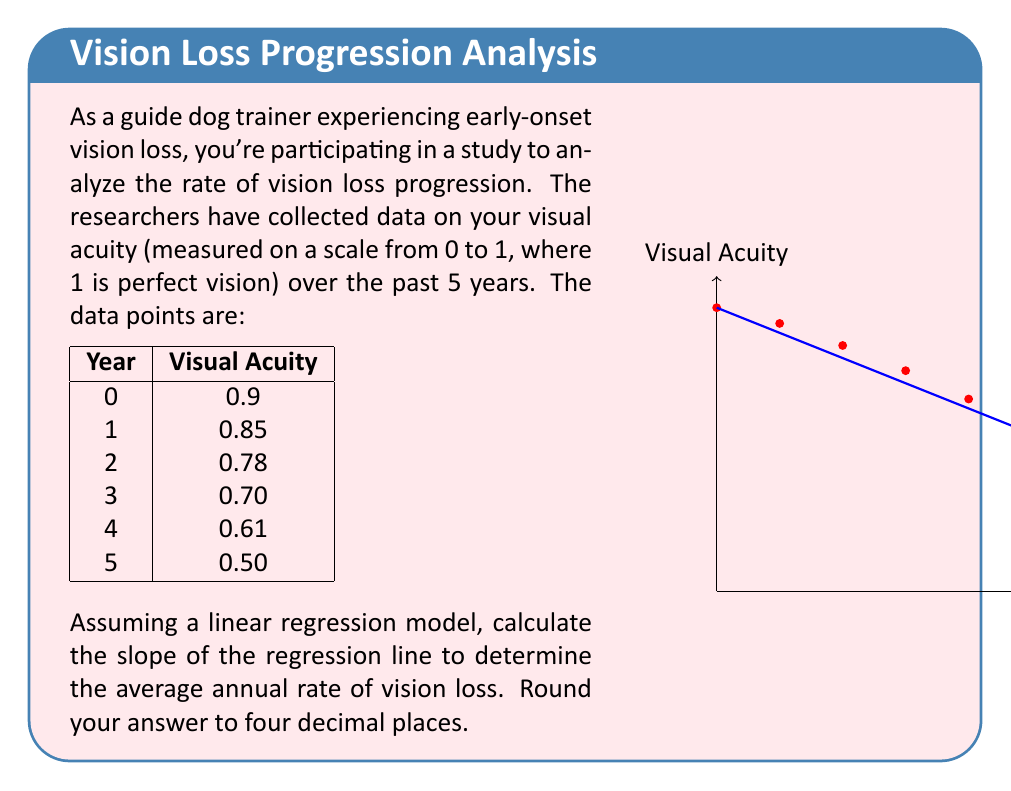Can you solve this math problem? To calculate the slope of the regression line, we'll use the formula for the slope in simple linear regression:

$$ m = \frac{n\sum xy - \sum x \sum y}{n\sum x^2 - (\sum x)^2} $$

Where:
$n$ is the number of data points
$x$ represents the years
$y$ represents the visual acuity

Step 1: Calculate the necessary sums:
$n = 6$
$\sum x = 0 + 1 + 2 + 3 + 4 + 5 = 15$
$\sum y = 0.9 + 0.85 + 0.78 + 0.70 + 0.61 + 0.50 = 4.34$
$\sum xy = (0 \times 0.9) + (1 \times 0.85) + (2 \times 0.78) + (3 \times 0.70) + (4 \times 0.61) + (5 \times 0.50) = 8.54$
$\sum x^2 = 0^2 + 1^2 + 2^2 + 3^2 + 4^2 + 5^2 = 55$

Step 2: Plug these values into the slope formula:

$$ m = \frac{6(8.54) - 15(4.34)}{6(55) - 15^2} $$

Step 3: Simplify:

$$ m = \frac{51.24 - 65.10}{330 - 225} $$
$$ m = \frac{-13.86}{105} $$
$$ m = -0.132 $$

Step 4: Round to four decimal places:

$m = -0.0800$

The negative slope indicates a decrease in visual acuity over time.
Answer: -0.0800 